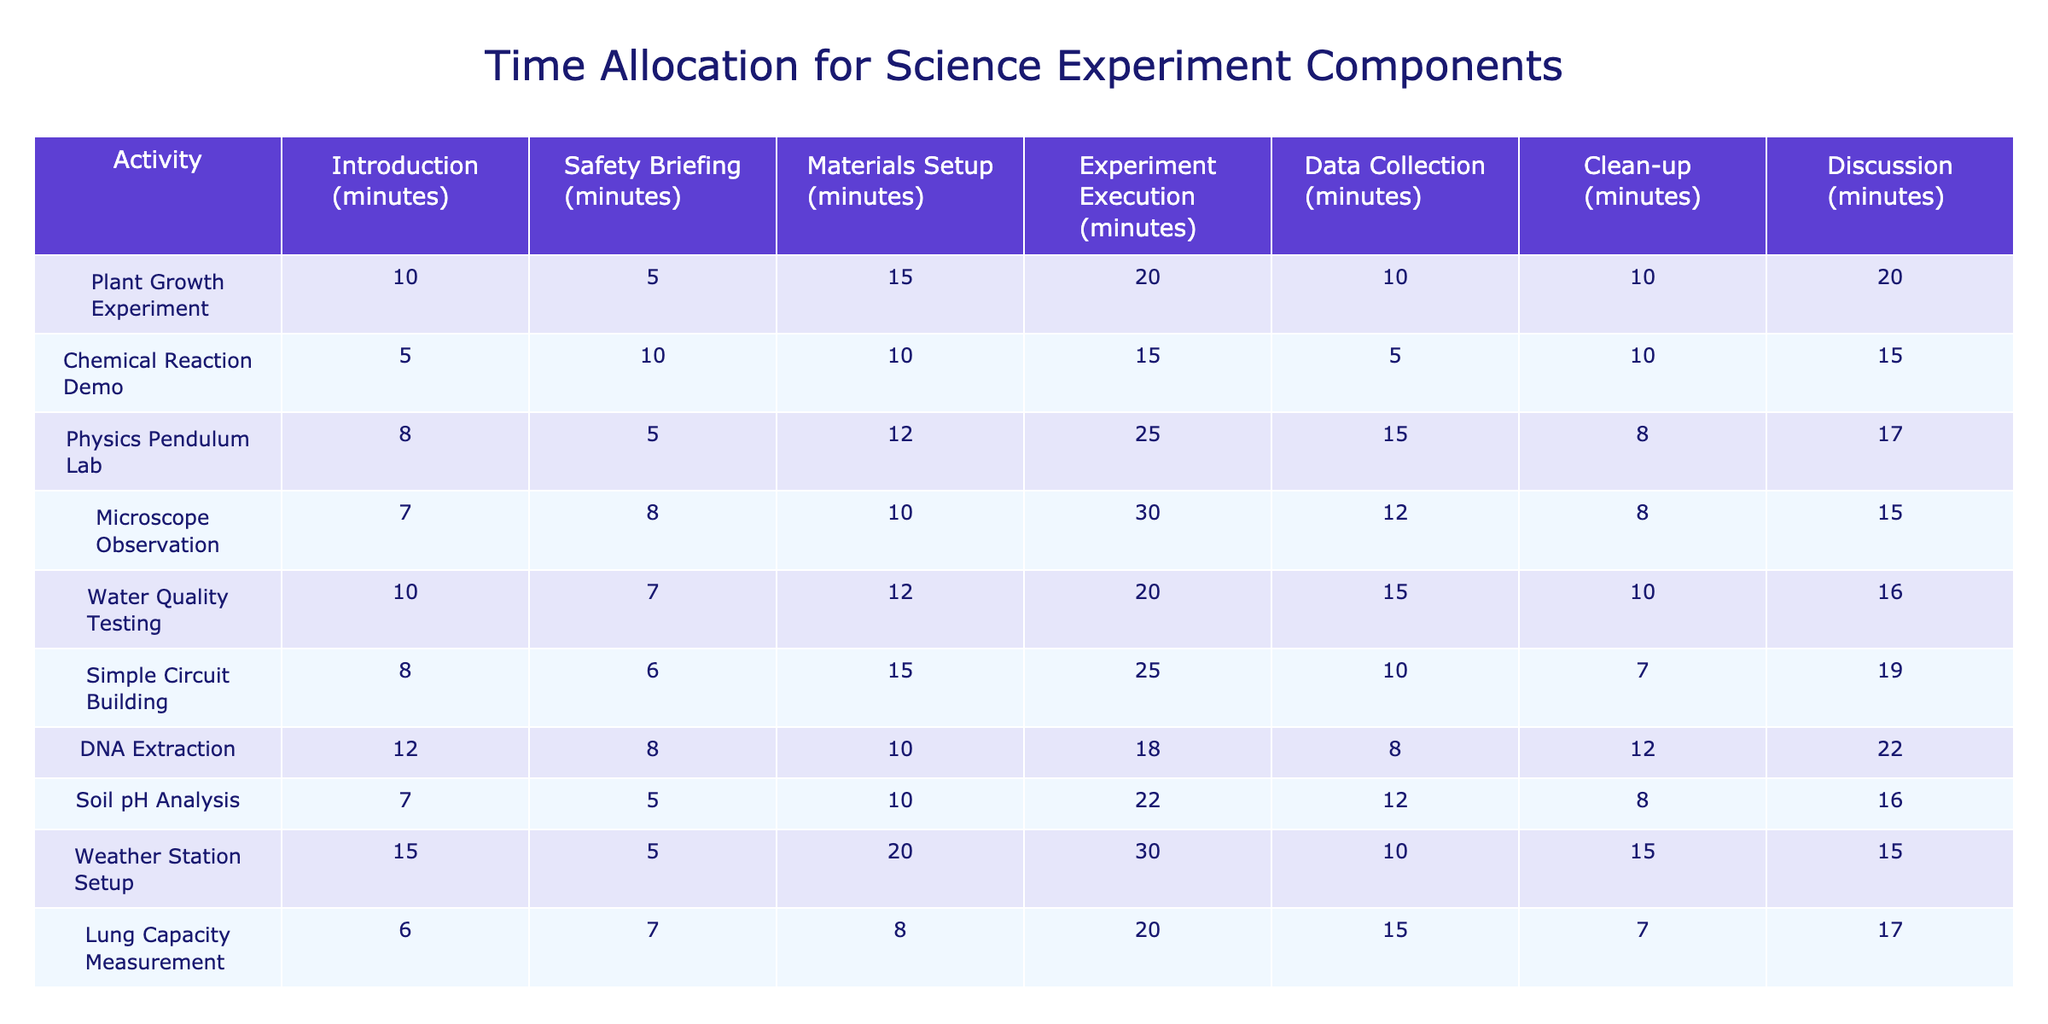What is the longest single activity duration in the Plant Growth Experiment? The duration of each activity in the Plant Growth Experiment is as follows: Introduction (10), Safety Briefing (5), Materials Setup (15), Experiment Execution (20), Data Collection (10), Clean-up (10), Discussion (20). The longest duration is in Experiment Execution and Discussion, both at 20 minutes.
Answer: 20 minutes Which experiment had the shortest introduction time? By reviewing the introduction times of all experiments, the Chemical Reaction Demo has the shortest introduction time at 5 minutes.
Answer: 5 minutes What is the average time allocated for clean-up across all experiments? To calculate the average clean-up time, we add the clean-up times from each experiment (10 + 10 + 8 + 8 + 10 + 7 + 12 + 8 + 15 + 7 = 89 minutes). We then divide by the number of experiments (10) to get the average: 89/10 = 8.9 minutes.
Answer: 8.9 minutes Does the Physics Pendulum Lab spend more time on experiment execution than on discussion? The Physics Pendulum Lab spends 25 minutes on experiment execution and 17 minutes on discussion. Since 25 is greater than 17, the statement is true.
Answer: Yes Which experiment has the highest total time allocation across all activities? To find the highest total, we sum the times for each experiment: Plant Growth (70), Chemical Reaction (50), Physics Pendulum (75), Microscope Observation (77), Water Quality Testing (70), Simple Circuit (74), DNA Extraction (78), Soil pH Analysis (69), Weather Station (85), Lung Capacity Measurement (73). The highest total is for the Microscope Observation with 77 minutes.
Answer: 85 minutes What is the difference in total time allocation between the DNA Extraction and the Weather Station Setup experiments? Total time for DNA Extraction is 78 minutes and for Weather Station Setup is 85 minutes. The difference is 85 - 78 = 7 minutes, indicating Weather Station Setup takes more time.
Answer: 7 minutes Are more experiments allocated at least 10 minutes for discussion? There are 10 experiments, and reviewing their discussion times indicates 8 out of 10 experiments are allocated at least 10 minutes for discussion. Thus, the statement is true.
Answer: Yes Which activity is consistently taking the same amount of time across the experiments? Reviewing the table, no single activity maintains a consistent duration across all experiments, as each experiment has varying times for every activity.
Answer: No Which experiment had the highest minute allocation for safety briefing? Looking at the safety briefing times across all experiments, the Chemical Reaction Demo takes 10 minutes, which is the maximum.
Answer: 10 minutes In which experiment is the clean-up time the least, and what is the duration? Reviewing the clean-up times, the Simple Circuit Building experiment has the least clean-up time at 7 minutes.
Answer: 7 minutes What was the combined time spent on Data Collection and Clean-up in the Water Quality Testing experiment? In Water Quality Testing, Data Collection time is 15 minutes and Clean-up time is 10 minutes. The combined time is 15 + 10 = 25 minutes.
Answer: 25 minutes 